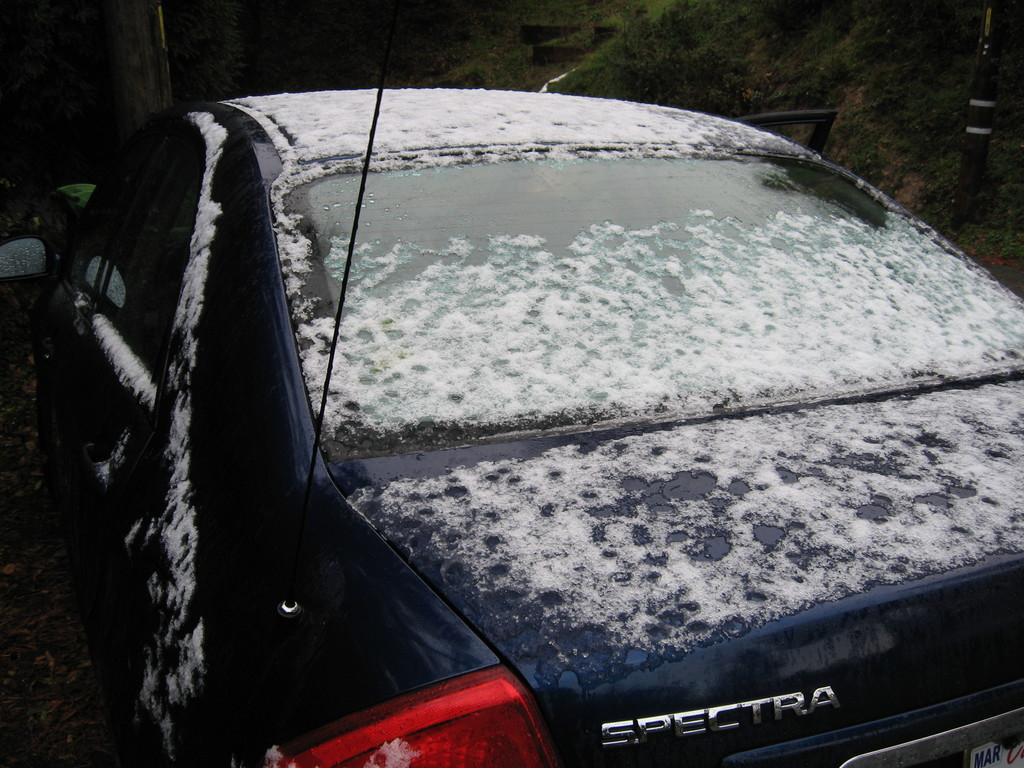What is the main subject of the image? The main subject of the image is a car. Can you describe the car's condition in the image? The car has snow on it. How does the car's digestion process work in the image? Cars do not have a digestion process, as they are inanimate objects. What is the car's throat like in the image? Cars do not have a throat, as they are inanimate objects. 